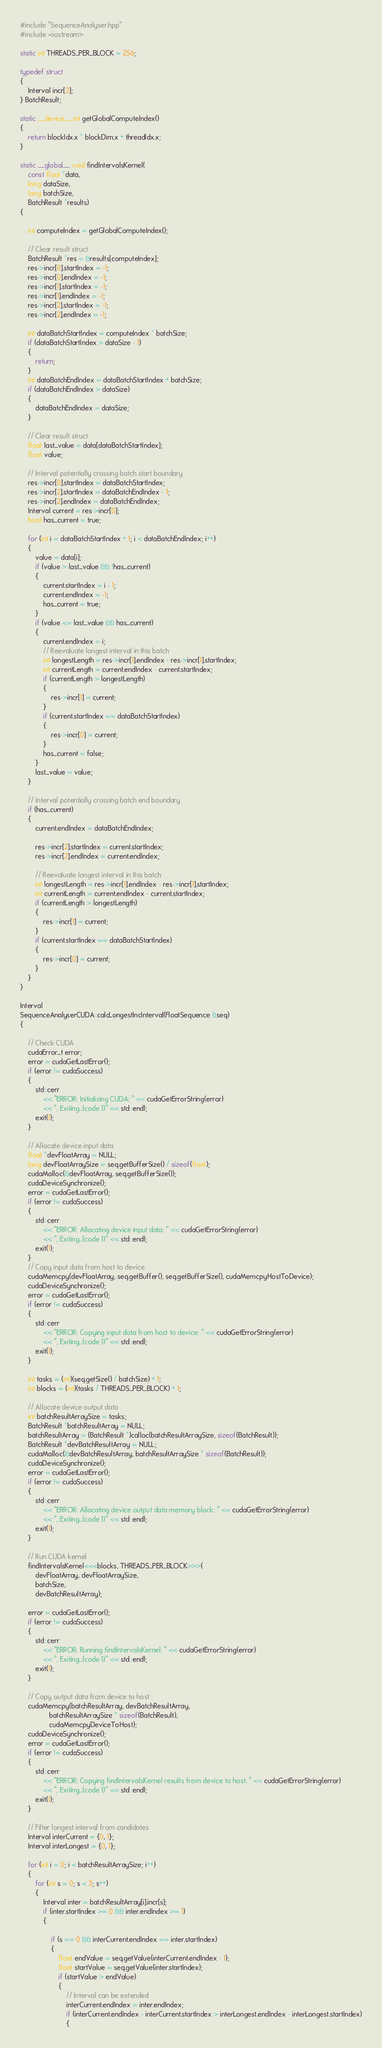<code> <loc_0><loc_0><loc_500><loc_500><_Cuda_>
#include "SequenceAnalyser.hpp"
#include <iostream>

static int THREADS_PER_BLOCK = 256;

typedef struct
{
    Interval incr[3];
} BatchResult;

static __device__ int getGlobalComputeIndex()
{
    return blockIdx.x * blockDim.x + threadIdx.x;
}

static __global__ void findIntervalsKernel(
    const float *data,
    long dataSize,
    long batchSize,
    BatchResult *results)
{

    int computeIndex = getGlobalComputeIndex();

    // Clear result struct
    BatchResult *res = &results[computeIndex];
    res->incr[0].startIndex = -1;
    res->incr[0].endIndex = -1;
    res->incr[1].startIndex = -1;
    res->incr[1].endIndex = -1;
    res->incr[2].startIndex = -1;
    res->incr[2].endIndex = -1;

    int dataBatchStartIndex = computeIndex * batchSize;
    if (dataBatchStartIndex > dataSize - 1)
    {
        return;
    }
    int dataBatchEndIndex = dataBatchStartIndex + batchSize;
    if (dataBatchEndIndex > dataSize)
    {
        dataBatchEndIndex = dataSize;
    }

    // Clear result struct
    float last_value = data[dataBatchStartIndex];
    float value;

    // Interval potentially crossing batch start boundary
    res->incr[0].startIndex = dataBatchStartIndex;
    res->incr[2].startIndex = dataBatchEndIndex - 1;
    res->incr[2].endIndex = dataBatchEndIndex;
    Interval current = res->incr[0];
    bool has_current = true;

    for (int i = dataBatchStartIndex + 1; i < dataBatchEndIndex; i++)
    {
        value = data[i];
        if (value > last_value && !has_current)
        {
            current.startIndex = i - 1;
            current.endIndex = -1;
            has_current = true;
        }
        if (value <= last_value && has_current)
        {
            current.endIndex = i;
            // Reevaluate longest interval in this batch
            int longestLength = res->incr[1].endIndex - res->incr[1].startIndex;
            int currentLength = current.endIndex - current.startIndex;
            if (currentLength > longestLength)
            {
                res->incr[1] = current;
            }
            if (current.startIndex == dataBatchStartIndex)
            {
                res->incr[0] = current;
            }
            has_current = false;
        }
        last_value = value;
    }

    // Interval potentially crossing batch end boundary
    if (has_current)
    {
        current.endIndex = dataBatchEndIndex;

        res->incr[2].startIndex = current.startIndex;
        res->incr[2].endIndex = current.endIndex;

        // Reevaluate longest interval in this batch
        int longestLength = res->incr[1].endIndex - res->incr[1].startIndex;
        int currentLength = current.endIndex - current.startIndex;
        if (currentLength > longestLength)
        {
            res->incr[1] = current;
        }
        if (current.startIndex == dataBatchStartIndex)
        {
            res->incr[0] = current;
        }
    }
}

Interval
SequenceAnalyserCUDA::calcLongestIncInterval(FloatSequence &seq)
{

    // Check CUDA
    cudaError_t error;
    error = cudaGetLastError();
    if (error != cudaSuccess)
    {
        std::cerr 
            << "ERROR: Initializing CUDA: " << cudaGetErrorString(error) 
            << ", Exiting...(code 1)" << std::endl;
        exit(1);
    }

    // Allocate device input data
    float *devFloatArray = NULL;
    long devFloatArraySize = seq.getBufferSize() / sizeof(float);
    cudaMalloc(&devFloatArray, seq.getBufferSize());
    cudaDeviceSynchronize();
    error = cudaGetLastError();
    if (error != cudaSuccess)
    {
        std::cerr 
            << "ERROR: Allocating device input data: " << cudaGetErrorString(error) 
            << ", Exiting...(code 1)" << std::endl;
        exit(1);
    }
    // Copy input data from host to device
    cudaMemcpy(devFloatArray, seq.getBuffer(), seq.getBufferSize(), cudaMemcpyHostToDevice);
    cudaDeviceSynchronize();
    error = cudaGetLastError();
    if (error != cudaSuccess)
    {
        std::cerr 
            << "ERROR: Copying input data from host to device: " << cudaGetErrorString(error) 
            << ", Exiting...(code 1)" << std::endl;
        exit(1);
    }

    int tasks = (int)(seq.getSize() / batchSize) + 1;
    int blocks = (int)(tasks / THREADS_PER_BLOCK) + 1;

    // Allocate device output data
    int batchResultArraySize = tasks;
    BatchResult *batchResultArray = NULL;
    batchResultArray = (BatchResult *)calloc(batchResultArraySize, sizeof(BatchResult));
    BatchResult *devBatchResultArray = NULL;
    cudaMalloc(&devBatchResultArray, batchResultArraySize * sizeof(BatchResult));
    cudaDeviceSynchronize();
    error = cudaGetLastError();
    if (error != cudaSuccess)
    {
        std::cerr 
            << "ERROR: Allocating device output data memory block: " << cudaGetErrorString(error) 
            << ", Exiting...(code 1)" << std::endl;
        exit(1);
    }

    // Run CUDA kernel
    findIntervalsKernel<<<blocks, THREADS_PER_BLOCK>>>(
        devFloatArray, devFloatArraySize,
        batchSize,
        devBatchResultArray);

    error = cudaGetLastError();
    if (error != cudaSuccess)
    {
        std::cerr 
            << "ERROR: Running findIntervalsKernel: " << cudaGetErrorString(error) 
            << ", Exiting...(code 1)" << std::endl;
        exit(1);
    }

    // Copy output data from device to host
    cudaMemcpy(batchResultArray, devBatchResultArray,
               batchResultArraySize * sizeof(BatchResult),
               cudaMemcpyDeviceToHost);
    cudaDeviceSynchronize();
    error = cudaGetLastError();
    if (error != cudaSuccess)
    {
        std::cerr 
            << "ERROR: Copying findIntervalsKernel results from device to host: " << cudaGetErrorString(error) 
            << ", Exiting...(code 1)" << std::endl;
        exit(1);
    }

    // Filter longest interval from candidates
    Interval interCurrent = {0, 1};
    Interval interLongest = {0, 1};

    for (int i = 0; i < batchResultArraySize; i++)
    {
        for (int s = 0; s < 3; s++)
        {
            Interval inter = batchResultArray[i].incr[s];
            if (inter.startIndex >= 0 && inter.endIndex >= 1)
            {

                if (s == 0 && interCurrent.endIndex == inter.startIndex)
                {
                    float endValue = seq.getValue(interCurrent.endIndex - 1);
                    float startValue = seq.getValue(inter.startIndex);
                    if (startValue > endValue)
                    {
                        // Interval can be extended
                        interCurrent.endIndex = inter.endIndex;
                        if (interCurrent.endIndex - interCurrent.startIndex > interLongest.endIndex - interLongest.startIndex)
                        {</code> 